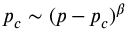Convert formula to latex. <formula><loc_0><loc_0><loc_500><loc_500>p _ { c } \sim ( p - p _ { c } ) ^ { \beta }</formula> 